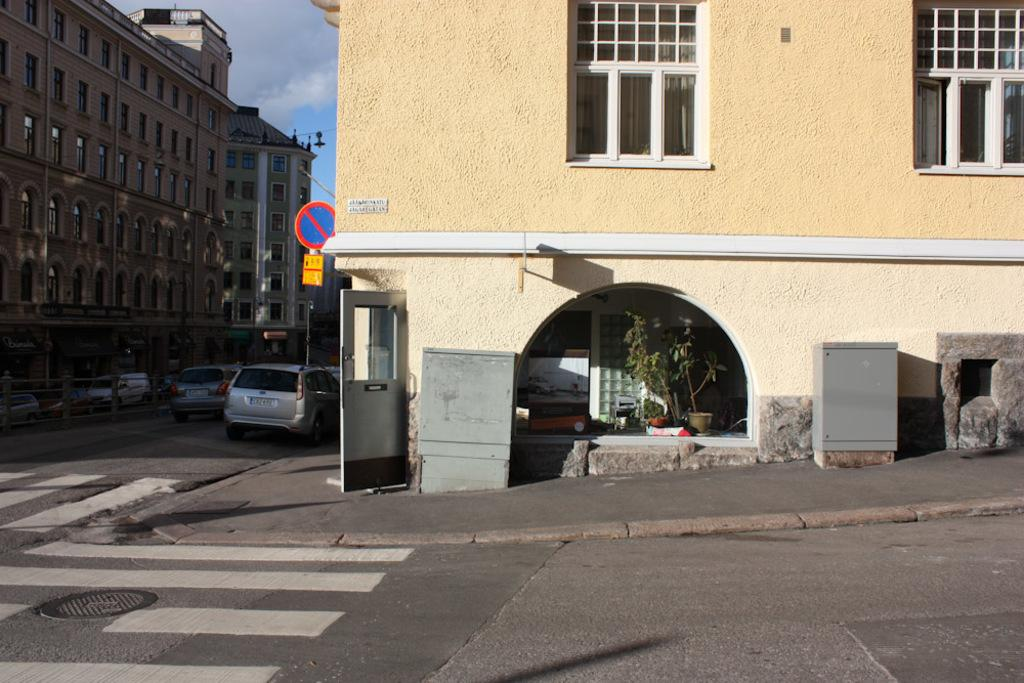What type of structures can be seen in the image? There are buildings in the image. What is happening on the road in the image? There are vehicles on the road in the image. What is present to provide information or directions in the image? There is a sign board in the image. What type of plants are visible in the image? There are house plants in the image. What is a feature of the buildings that allows access or egress? There is a door in the image. What allows light and air to enter the buildings in the image? There are windows in the image. What safety feature is present for pedestrians in the image? There is a zebra crossing in the image. Where is the bucket located in the image? There is no bucket present in the image. What type of nerve is visible in the image? There are no nerves visible in the image; it features buildings, vehicles, a sign board, house plants, a door, windows, and a zebra crossing. --- Facts: 1. There is a person holding a book in the image. 2. The person is sitting on a chair. 3. There is a table in the image. 4. The table has a lamp on it. 5. The background of the image is a wall. Absurd Topics: parrot, volcano, ocean Conversation: What is the person in the image holding? The person is holding a book in the image. What is the person sitting on in the image? The person is sitting on a chair in the image. What is present on the table in the image? The table has a lamp on it in the image. What is the background of the image? The background of the image is a wall. Reasoning: Let's think step by step in order to produce the conversation. We start by identifying the main subject in the image, which is the person holding a book. Then, we expand the conversation to include other items that are also visible, such as the chair, table, lamp, and wall. Each question is designed to elicit a specific detail about the image that is known from the provided facts. Absurd Question/Answer: Can you see a parrot perched on the lamp in the image? There is no parrot present in the image; it features a person holding a book, sitting on a chair, a table with a lamp, and a wall as the background. Is there an active volcano visible in the image? There is no volcano present in the image; it features a person holding a book, sitting on a chair, a table with a lamp, and a wall as the background. 